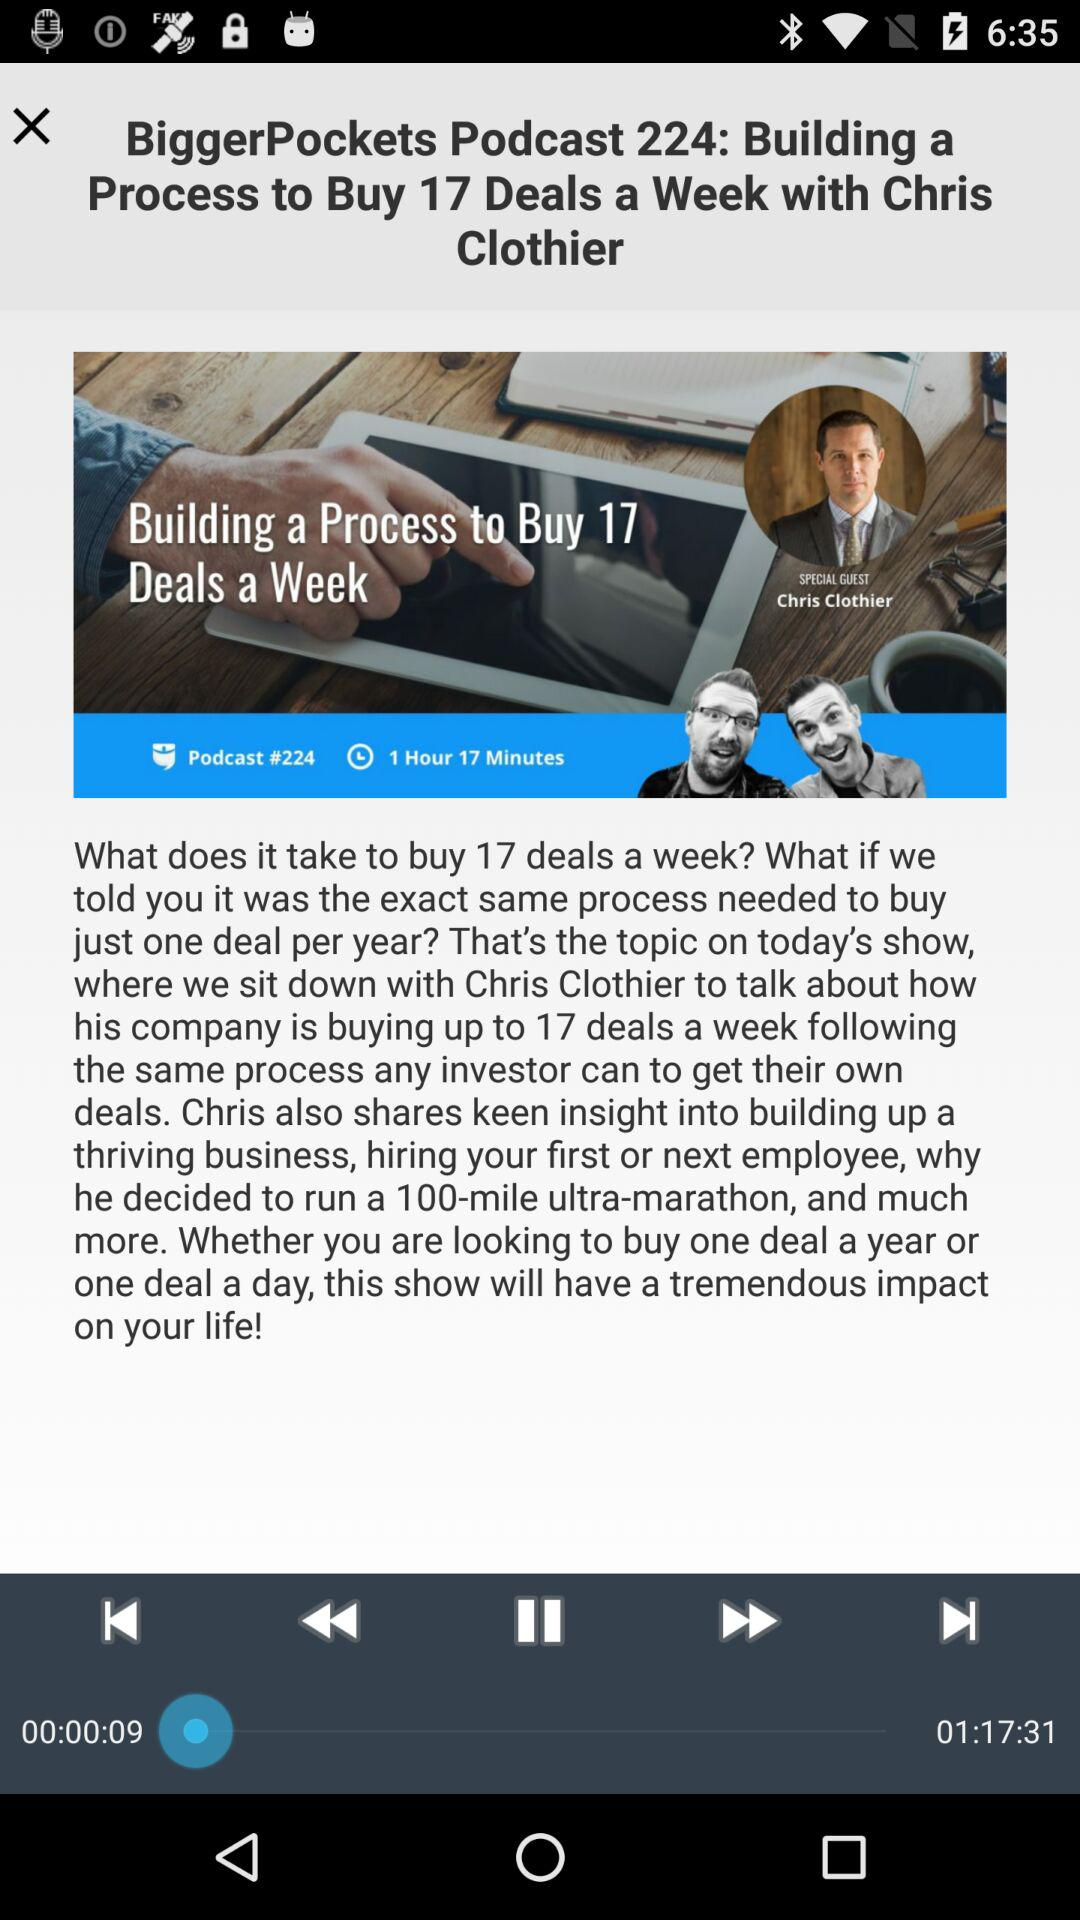What is the name of the article shown on the screen? The name of the article is "Building a Process to Buy 17 Deals a Week". 